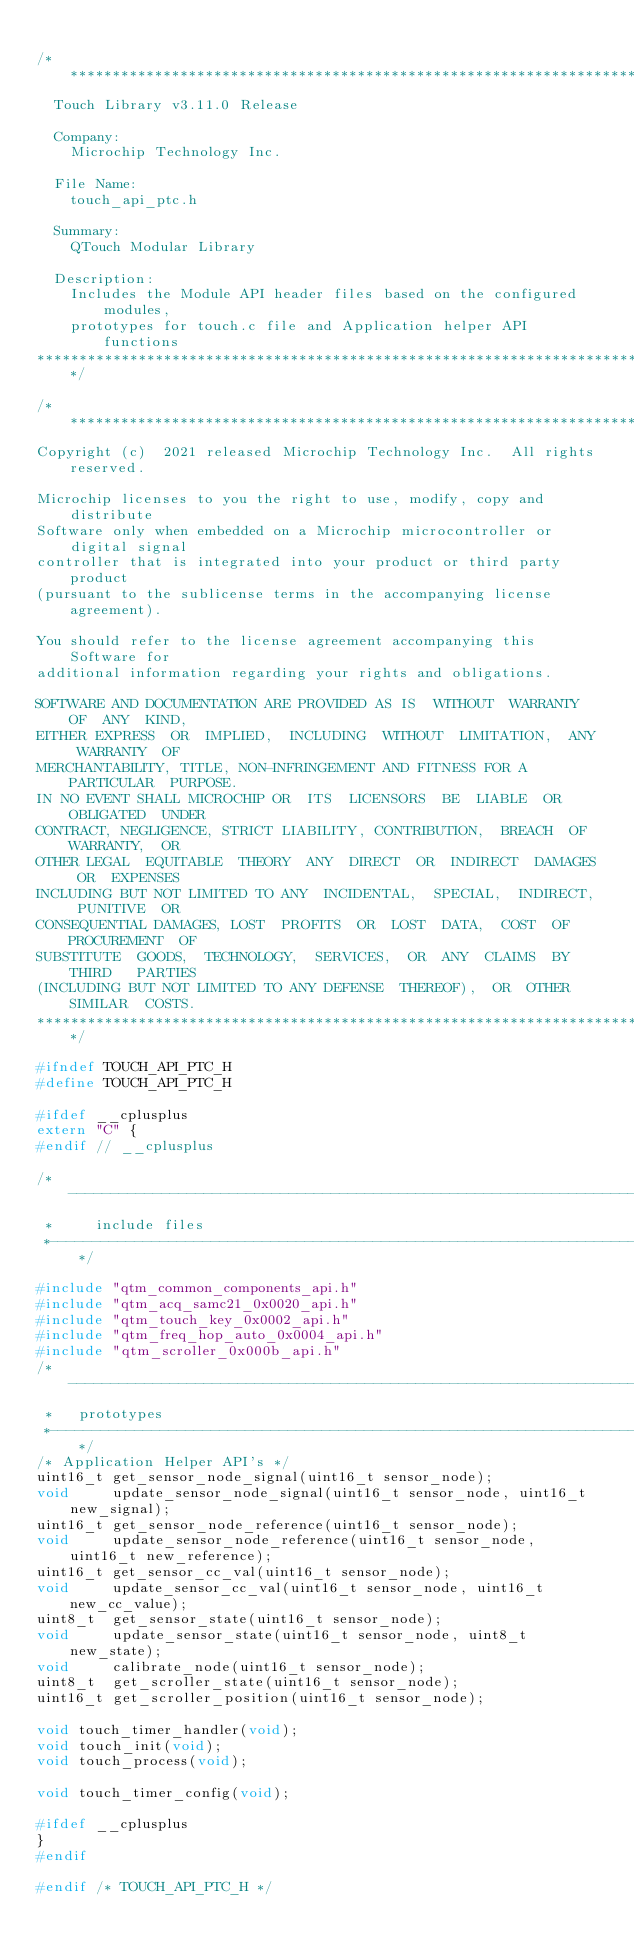<code> <loc_0><loc_0><loc_500><loc_500><_C_>
/*******************************************************************************
  Touch Library v3.11.0 Release

  Company:
    Microchip Technology Inc.

  File Name:
    touch_api_ptc.h

  Summary:
    QTouch Modular Library

  Description:
    Includes the Module API header files based on the configured modules,
    prototypes for touch.c file and Application helper API functions
*******************************************************************************/

/*******************************************************************************
Copyright (c)  2021 released Microchip Technology Inc.  All rights reserved.

Microchip licenses to you the right to use, modify, copy and distribute
Software only when embedded on a Microchip microcontroller or digital signal
controller that is integrated into your product or third party product
(pursuant to the sublicense terms in the accompanying license agreement).

You should refer to the license agreement accompanying this Software for
additional information regarding your rights and obligations.

SOFTWARE AND DOCUMENTATION ARE PROVIDED AS IS  WITHOUT  WARRANTY  OF  ANY  KIND,
EITHER EXPRESS  OR  IMPLIED,  INCLUDING  WITHOUT  LIMITATION,  ANY  WARRANTY  OF
MERCHANTABILITY, TITLE, NON-INFRINGEMENT AND FITNESS FOR A  PARTICULAR  PURPOSE.
IN NO EVENT SHALL MICROCHIP OR  ITS  LICENSORS  BE  LIABLE  OR  OBLIGATED  UNDER
CONTRACT, NEGLIGENCE, STRICT LIABILITY, CONTRIBUTION,  BREACH  OF  WARRANTY,  OR
OTHER LEGAL  EQUITABLE  THEORY  ANY  DIRECT  OR  INDIRECT  DAMAGES  OR  EXPENSES
INCLUDING BUT NOT LIMITED TO ANY  INCIDENTAL,  SPECIAL,  INDIRECT,  PUNITIVE  OR
CONSEQUENTIAL DAMAGES, LOST  PROFITS  OR  LOST  DATA,  COST  OF  PROCUREMENT  OF
SUBSTITUTE  GOODS,  TECHNOLOGY,  SERVICES,  OR  ANY  CLAIMS  BY  THIRD   PARTIES
(INCLUDING BUT NOT LIMITED TO ANY DEFENSE  THEREOF),  OR  OTHER  SIMILAR  COSTS.
*******************************************************************************/

#ifndef TOUCH_API_PTC_H
#define TOUCH_API_PTC_H

#ifdef __cplusplus
extern "C" {
#endif // __cplusplus

/*----------------------------------------------------------------------------
 *     include files
 *----------------------------------------------------------------------------*/

#include "qtm_common_components_api.h"
#include "qtm_acq_samc21_0x0020_api.h"
#include "qtm_touch_key_0x0002_api.h"
#include "qtm_freq_hop_auto_0x0004_api.h"
#include "qtm_scroller_0x000b_api.h"
/*----------------------------------------------------------------------------
 *   prototypes
 *----------------------------------------------------------------------------*/
/* Application Helper API's */
uint16_t get_sensor_node_signal(uint16_t sensor_node);
void     update_sensor_node_signal(uint16_t sensor_node, uint16_t new_signal);
uint16_t get_sensor_node_reference(uint16_t sensor_node);
void     update_sensor_node_reference(uint16_t sensor_node, uint16_t new_reference);
uint16_t get_sensor_cc_val(uint16_t sensor_node);
void     update_sensor_cc_val(uint16_t sensor_node, uint16_t new_cc_value);
uint8_t  get_sensor_state(uint16_t sensor_node);
void     update_sensor_state(uint16_t sensor_node, uint8_t new_state);
void     calibrate_node(uint16_t sensor_node);
uint8_t  get_scroller_state(uint16_t sensor_node);
uint16_t get_scroller_position(uint16_t sensor_node);

void touch_timer_handler(void);
void touch_init(void);
void touch_process(void);

void touch_timer_config(void);

#ifdef __cplusplus
}
#endif

#endif /* TOUCH_API_PTC_H */
</code> 